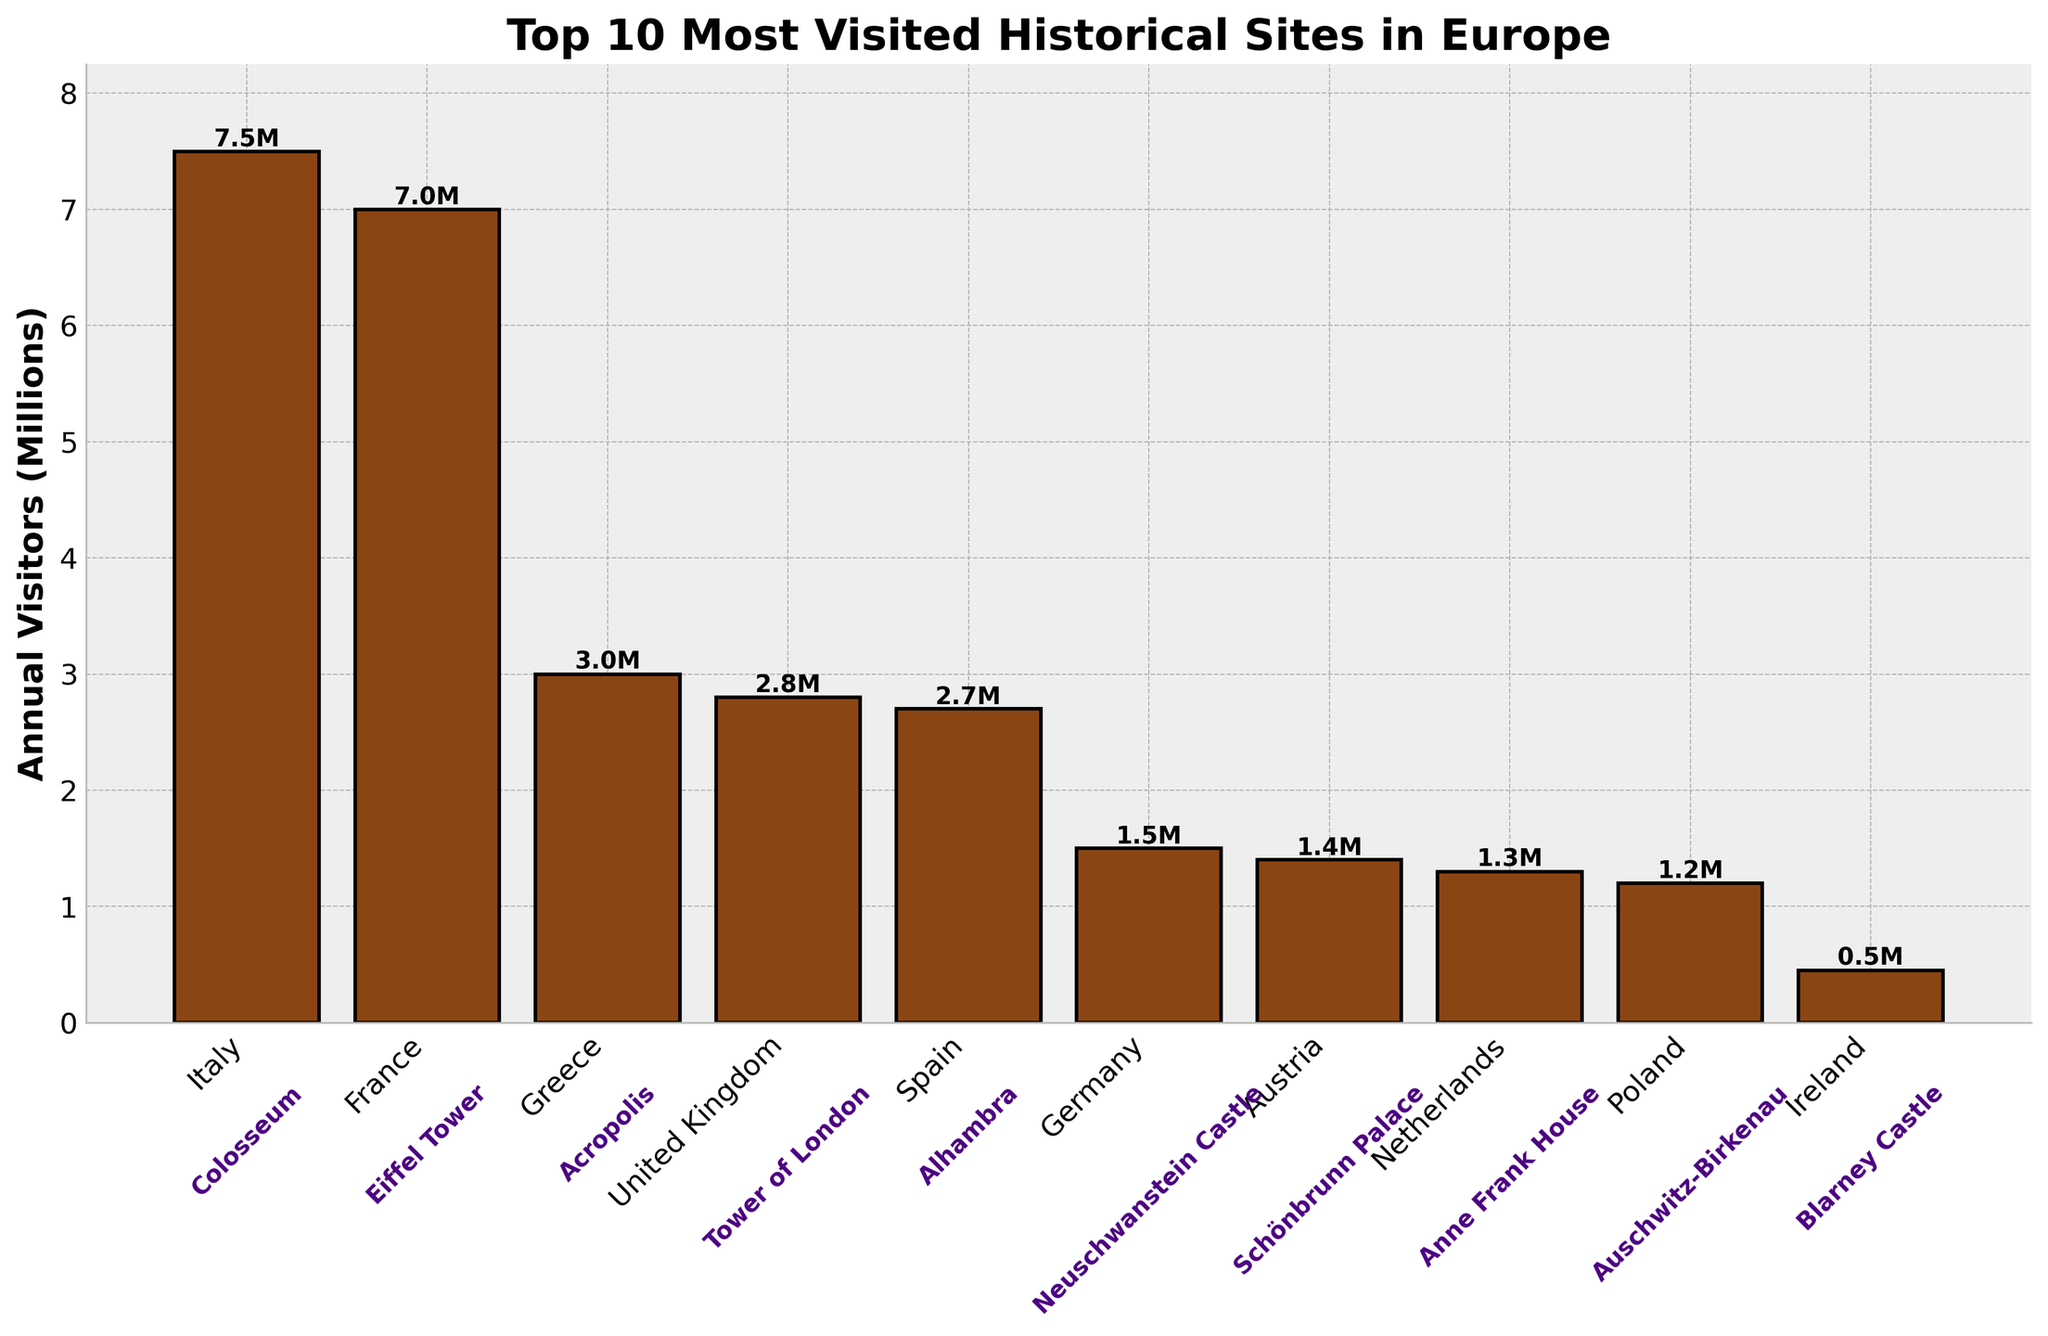Which historical site receives the most annual visitors? The figure shows the annual visitors in millions for each site. The highest bar corresponds to the Colosseum in Italy.
Answer: Colosseum Which country is home to the historical site with the least number of annual visitors on the list? The figure shows that the Blarney Castle in Ireland has the shortest bar, representing the lowest number of annual visitors.
Answer: Ireland How many annual visitors does the Alhambra in Spain get? The figure includes a bar for Spain labeled at the bottom with the number of annual visitors on the side of the corresponding bar. It shows 2.7 million visitors.
Answer: 2.7 million Which historical sites attract more visitors annually: Eiffel Tower in France or Colosseum in Italy? The bars representing the Eiffel Tower and Colosseum show their visitor numbers. The Colosseum’s bar is higher than that of the Eiffel Tower.
Answer: Colosseum What is the combined total of annual visitors for the Neuschwanstein Castle and Schönbrunn Palace? The figure gives the visitors for Neuschwanstein Castle in Germany (1.5 million) and Schönbrunn Palace in Austria (1.4 million). Adding these: 1.5 + 1.4 = 2.9 million.
Answer: 2.9 million How much more visitors does the Tower of London receive compared to the Anne Frank House? The figure shows the Tower of London with 2.8 million visitors and the Anne Frank House with 1.3 million visitors. Subtracting these: 2.8 - 1.3 = 1.5 million.
Answer: 1.5 million Among the countries shown, which one has the highest cumulative number of annual visitors from all its sites on this list? The figure shows all countries and their visitor counts: Italy (7.5M), France (7.0M), Greece (3.0M), UK (2.8M), Spain (2.7M), Germany (1.5M), Austria (1.4M), Netherlands (1.3M), Poland (1.2M), Ireland (0.45M). Italy has the highest cumulative total of 7.5 million.
Answer: Italy What is the height of the bar representing the Auschwitz-Birkenau in Poland and what does it signify? The figure shows the height of the bar representing Auschwitz-Birkenau in Poland as 1.2 million annual visitors.
Answer: 1.2 million visitors Would the median number of annual visitors for these sites be more than or less than 2 million? To find the median, list the visitor counts: 7.5M, 7.0M, 3.0M, 2.8M, 2.7M, 1.5M, 1.4M, 1.3M, 1.2M, 0.45M. The median is the 5th and 6th values' average (1.5M and 2.7M), so (2.7+1.5)/2 = 2.1M, which is more than 2 million.
Answer: More than 2 million Which historical site has nearly half the number of annual visitors as the Acropolis in Greece? The figure shows the Acropolis in Greece with 3.0 million visitors. The Anne Frank House in Netherlands has 1.3 million visitors, which is closest to half of 3.0 million (1.5 million).
Answer: Anne Frank House 